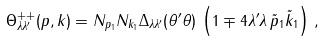<formula> <loc_0><loc_0><loc_500><loc_500>\Theta ^ { + + } _ { \lambda \lambda ^ { \prime } } ( p , k ) = N _ { p _ { 1 } } N _ { k _ { 1 } } \Delta _ { \lambda \lambda ^ { \prime } } ( \theta ^ { \prime } \theta ) \, \left ( 1 \mp 4 \lambda ^ { \prime } \lambda \, \tilde { p } _ { 1 } \tilde { k } _ { 1 } \right ) \, ,</formula> 